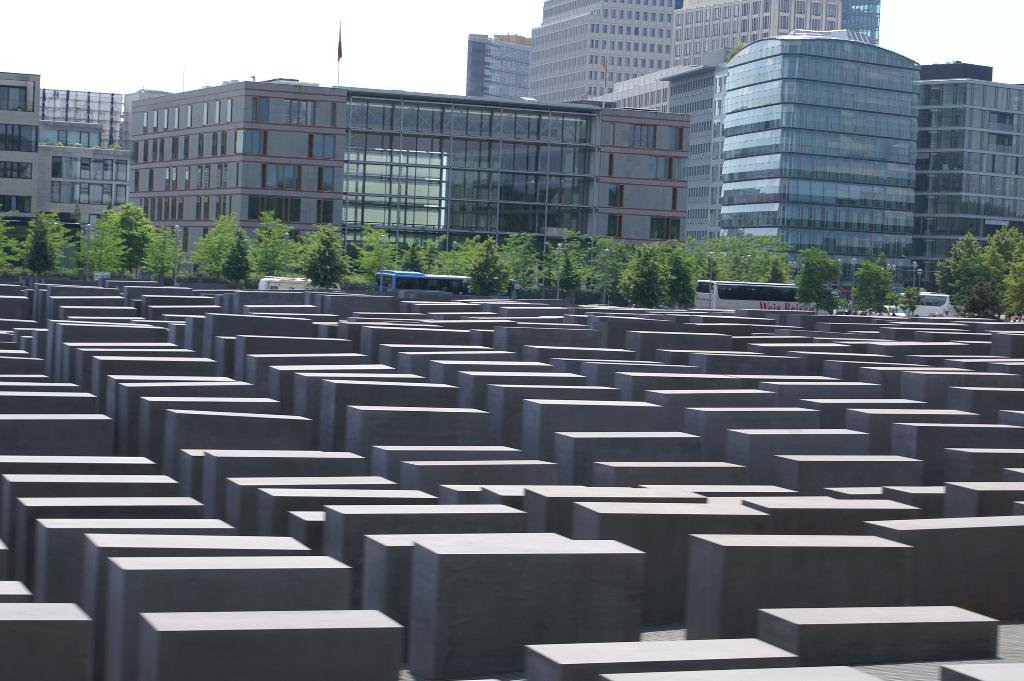What type of objects can be seen in the image? There are blocks, vehicles, trees, and buildings in the image. What else is present in the image besides the objects mentioned? There is a flag with a pole in the image. What can be seen in the background of the image? The sky is visible in the background of the image. Where is the hospital located in the image? There is no hospital present in the image. What type of jar can be seen on the shelf in the image? There is no shelf or jar present in the image. 